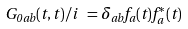Convert formula to latex. <formula><loc_0><loc_0><loc_500><loc_500>G _ { 0 \, a b } ( t , t ) / i \ = \delta _ { a b } f _ { a } ( t ) f _ { a } ^ { \ast } ( t )</formula> 